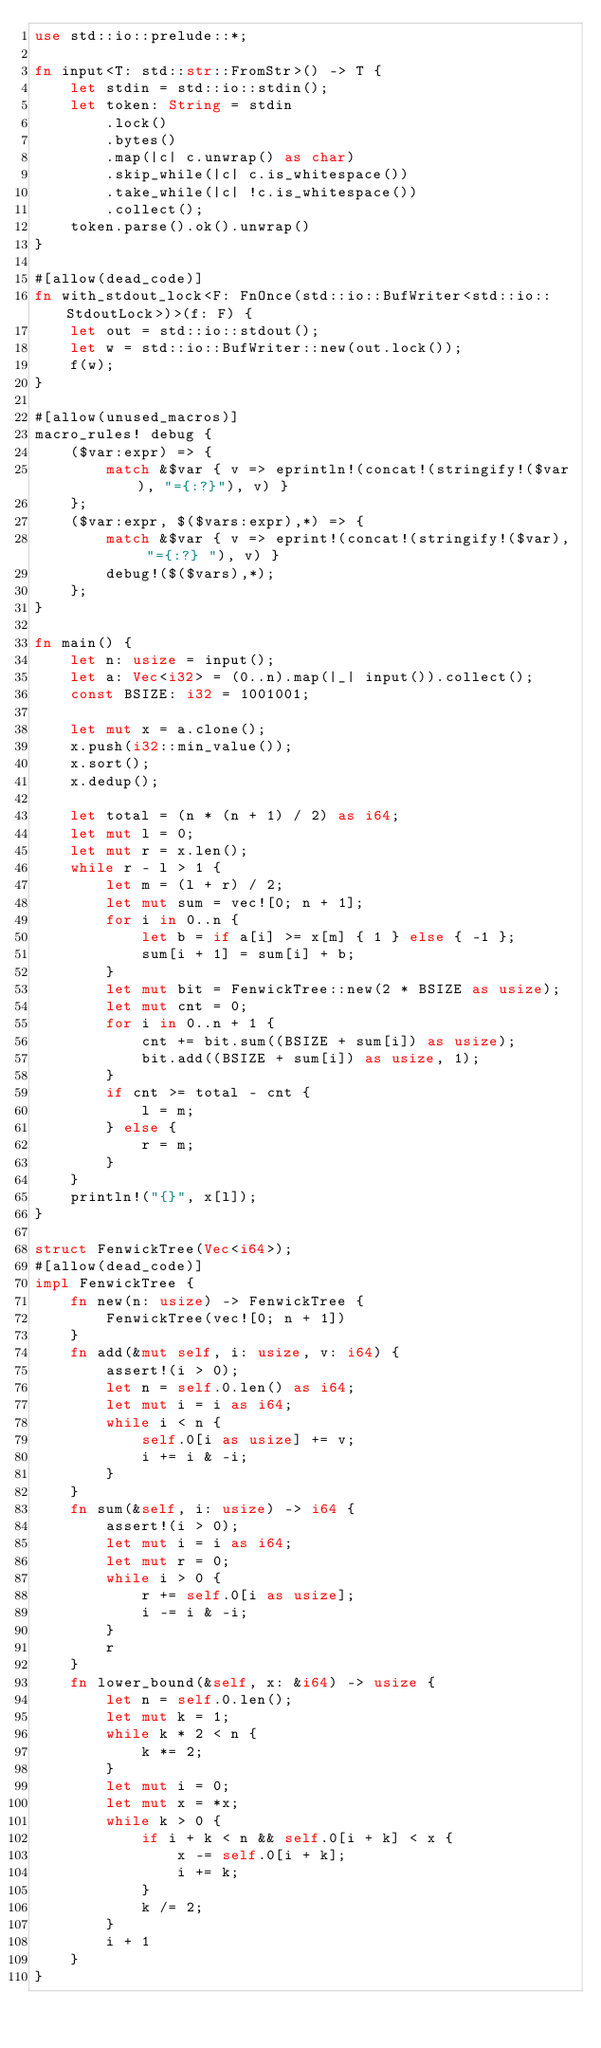<code> <loc_0><loc_0><loc_500><loc_500><_Rust_>use std::io::prelude::*;

fn input<T: std::str::FromStr>() -> T {
    let stdin = std::io::stdin();
    let token: String = stdin
        .lock()
        .bytes()
        .map(|c| c.unwrap() as char)
        .skip_while(|c| c.is_whitespace())
        .take_while(|c| !c.is_whitespace())
        .collect();
    token.parse().ok().unwrap()
}

#[allow(dead_code)]
fn with_stdout_lock<F: FnOnce(std::io::BufWriter<std::io::StdoutLock>)>(f: F) {
    let out = std::io::stdout();
    let w = std::io::BufWriter::new(out.lock());
    f(w);
}

#[allow(unused_macros)]
macro_rules! debug {
    ($var:expr) => {
        match &$var { v => eprintln!(concat!(stringify!($var), "={:?}"), v) }
    };
    ($var:expr, $($vars:expr),*) => {
        match &$var { v => eprint!(concat!(stringify!($var), "={:?} "), v) }
        debug!($($vars),*);
    };
}

fn main() {
    let n: usize = input();
    let a: Vec<i32> = (0..n).map(|_| input()).collect();
    const BSIZE: i32 = 1001001;

    let mut x = a.clone();
    x.push(i32::min_value());
    x.sort();
    x.dedup();

    let total = (n * (n + 1) / 2) as i64;
    let mut l = 0;
    let mut r = x.len();
    while r - l > 1 {
        let m = (l + r) / 2;
        let mut sum = vec![0; n + 1];
        for i in 0..n {
            let b = if a[i] >= x[m] { 1 } else { -1 };
            sum[i + 1] = sum[i] + b;
        }
        let mut bit = FenwickTree::new(2 * BSIZE as usize);
        let mut cnt = 0;
        for i in 0..n + 1 {
            cnt += bit.sum((BSIZE + sum[i]) as usize);
            bit.add((BSIZE + sum[i]) as usize, 1);
        }
        if cnt >= total - cnt {
            l = m;
        } else {
            r = m;
        }
    }
    println!("{}", x[l]);
}

struct FenwickTree(Vec<i64>);
#[allow(dead_code)]
impl FenwickTree {
    fn new(n: usize) -> FenwickTree {
        FenwickTree(vec![0; n + 1])
    }
    fn add(&mut self, i: usize, v: i64) {
        assert!(i > 0);
        let n = self.0.len() as i64;
        let mut i = i as i64;
        while i < n {
            self.0[i as usize] += v;
            i += i & -i;
        }
    }
    fn sum(&self, i: usize) -> i64 {
        assert!(i > 0);
        let mut i = i as i64;
        let mut r = 0;
        while i > 0 {
            r += self.0[i as usize];
            i -= i & -i;
        }
        r
    }
    fn lower_bound(&self, x: &i64) -> usize {
        let n = self.0.len();
        let mut k = 1;
        while k * 2 < n {
            k *= 2;
        }
        let mut i = 0;
        let mut x = *x;
        while k > 0 {
            if i + k < n && self.0[i + k] < x {
                x -= self.0[i + k];
                i += k;
            }
            k /= 2;
        }
        i + 1
    }
}
</code> 